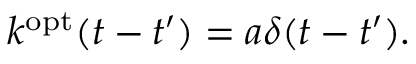<formula> <loc_0><loc_0><loc_500><loc_500>k ^ { o p t } ( t - t ^ { \prime } ) = a \delta ( t - t ^ { \prime } ) .</formula> 